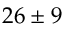Convert formula to latex. <formula><loc_0><loc_0><loc_500><loc_500>2 6 \pm 9</formula> 